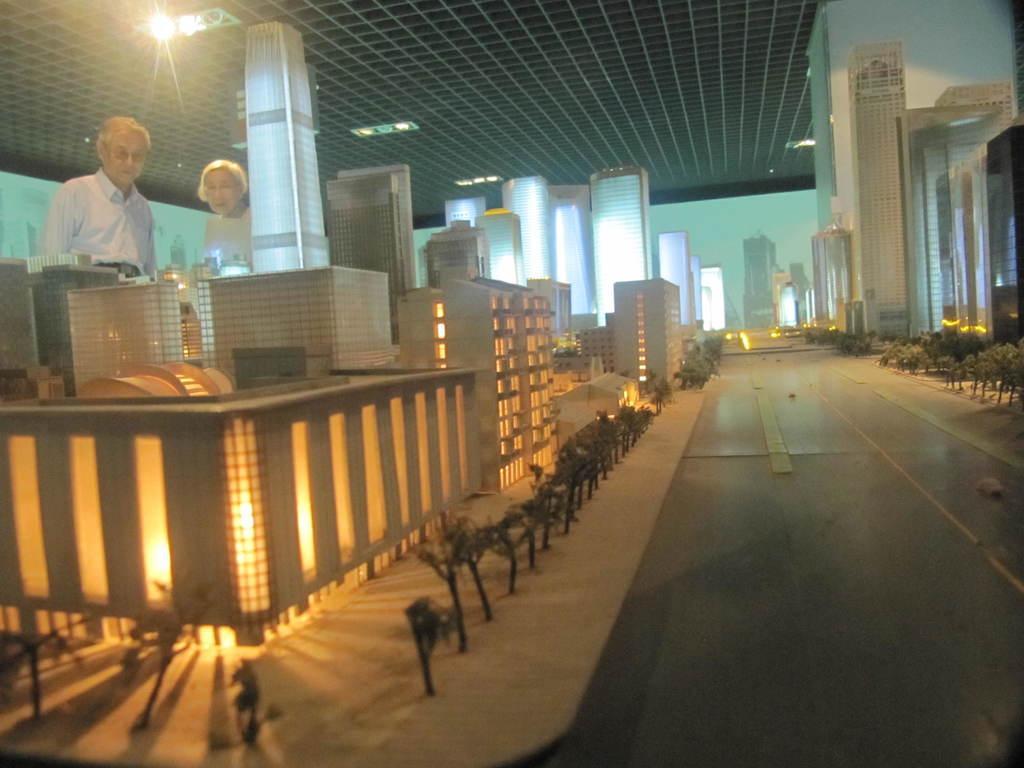Describe this image in one or two sentences. There is a project layout kept in display and two people were standing in front of the project and observing, in the background there is a blue wall and there is a single light lightened up to the roof. 